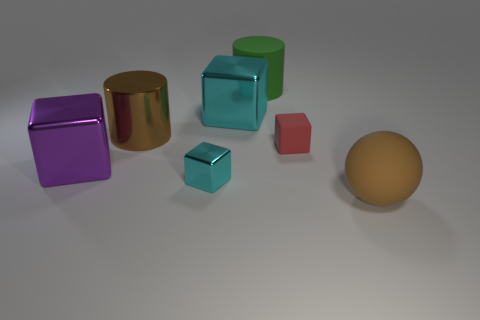There is a big rubber thing in front of the large matte object that is to the left of the big ball; is there a matte cylinder that is in front of it?
Offer a very short reply. No. There is another object that is the same shape as the green matte thing; what is its color?
Ensure brevity in your answer.  Brown. What number of green objects are either matte objects or metallic blocks?
Provide a succinct answer. 1. There is a large brown thing in front of the big brown object that is to the left of the matte ball; what is its material?
Provide a succinct answer. Rubber. Is the shape of the large green thing the same as the big brown shiny object?
Your answer should be very brief. Yes. There is a rubber cylinder that is the same size as the brown sphere; what is its color?
Provide a short and direct response. Green. Is there a small thing of the same color as the matte cylinder?
Give a very brief answer. No. Are there any big yellow metallic objects?
Give a very brief answer. No. Is the material of the cyan cube in front of the large purple block the same as the red block?
Offer a terse response. No. What is the size of the other block that is the same color as the tiny metal cube?
Your answer should be compact. Large. 